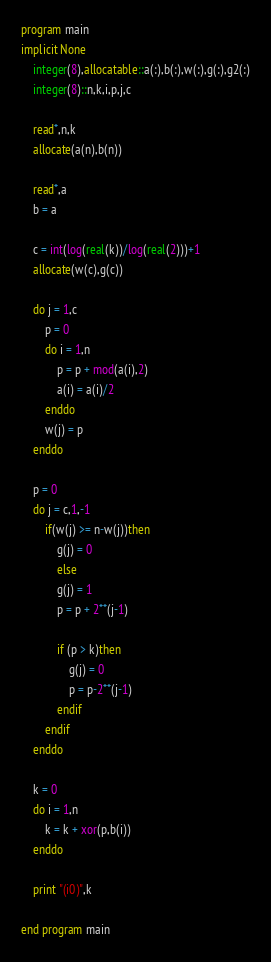Convert code to text. <code><loc_0><loc_0><loc_500><loc_500><_FORTRAN_>program main
implicit None
	integer(8),allocatable::a(:),b(:),w(:),g(:),g2(:)
	integer(8)::n,k,i,p,j,c
	
	read*,n,k
	allocate(a(n),b(n))
	
	read*,a
	b = a
	
	c = int(log(real(k))/log(real(2)))+1
	allocate(w(c),g(c))
	
	do j = 1,c
		p = 0
		do i = 1,n
			p = p + mod(a(i),2)
			a(i) = a(i)/2
		enddo
		w(j) = p
	enddo
	
	p = 0
	do j = c,1,-1
		if(w(j) >= n-w(j))then
			g(j) = 0
			else
			g(j) = 1
			p = p + 2**(j-1)
			
			if (p > k)then
				g(j) = 0
				p = p-2**(j-1)
			endif
		endif
	enddo
	
	k = 0
	do i = 1,n
		k = k + xor(p,b(i))
	enddo
	
	print "(i0)",k
	
end program main</code> 